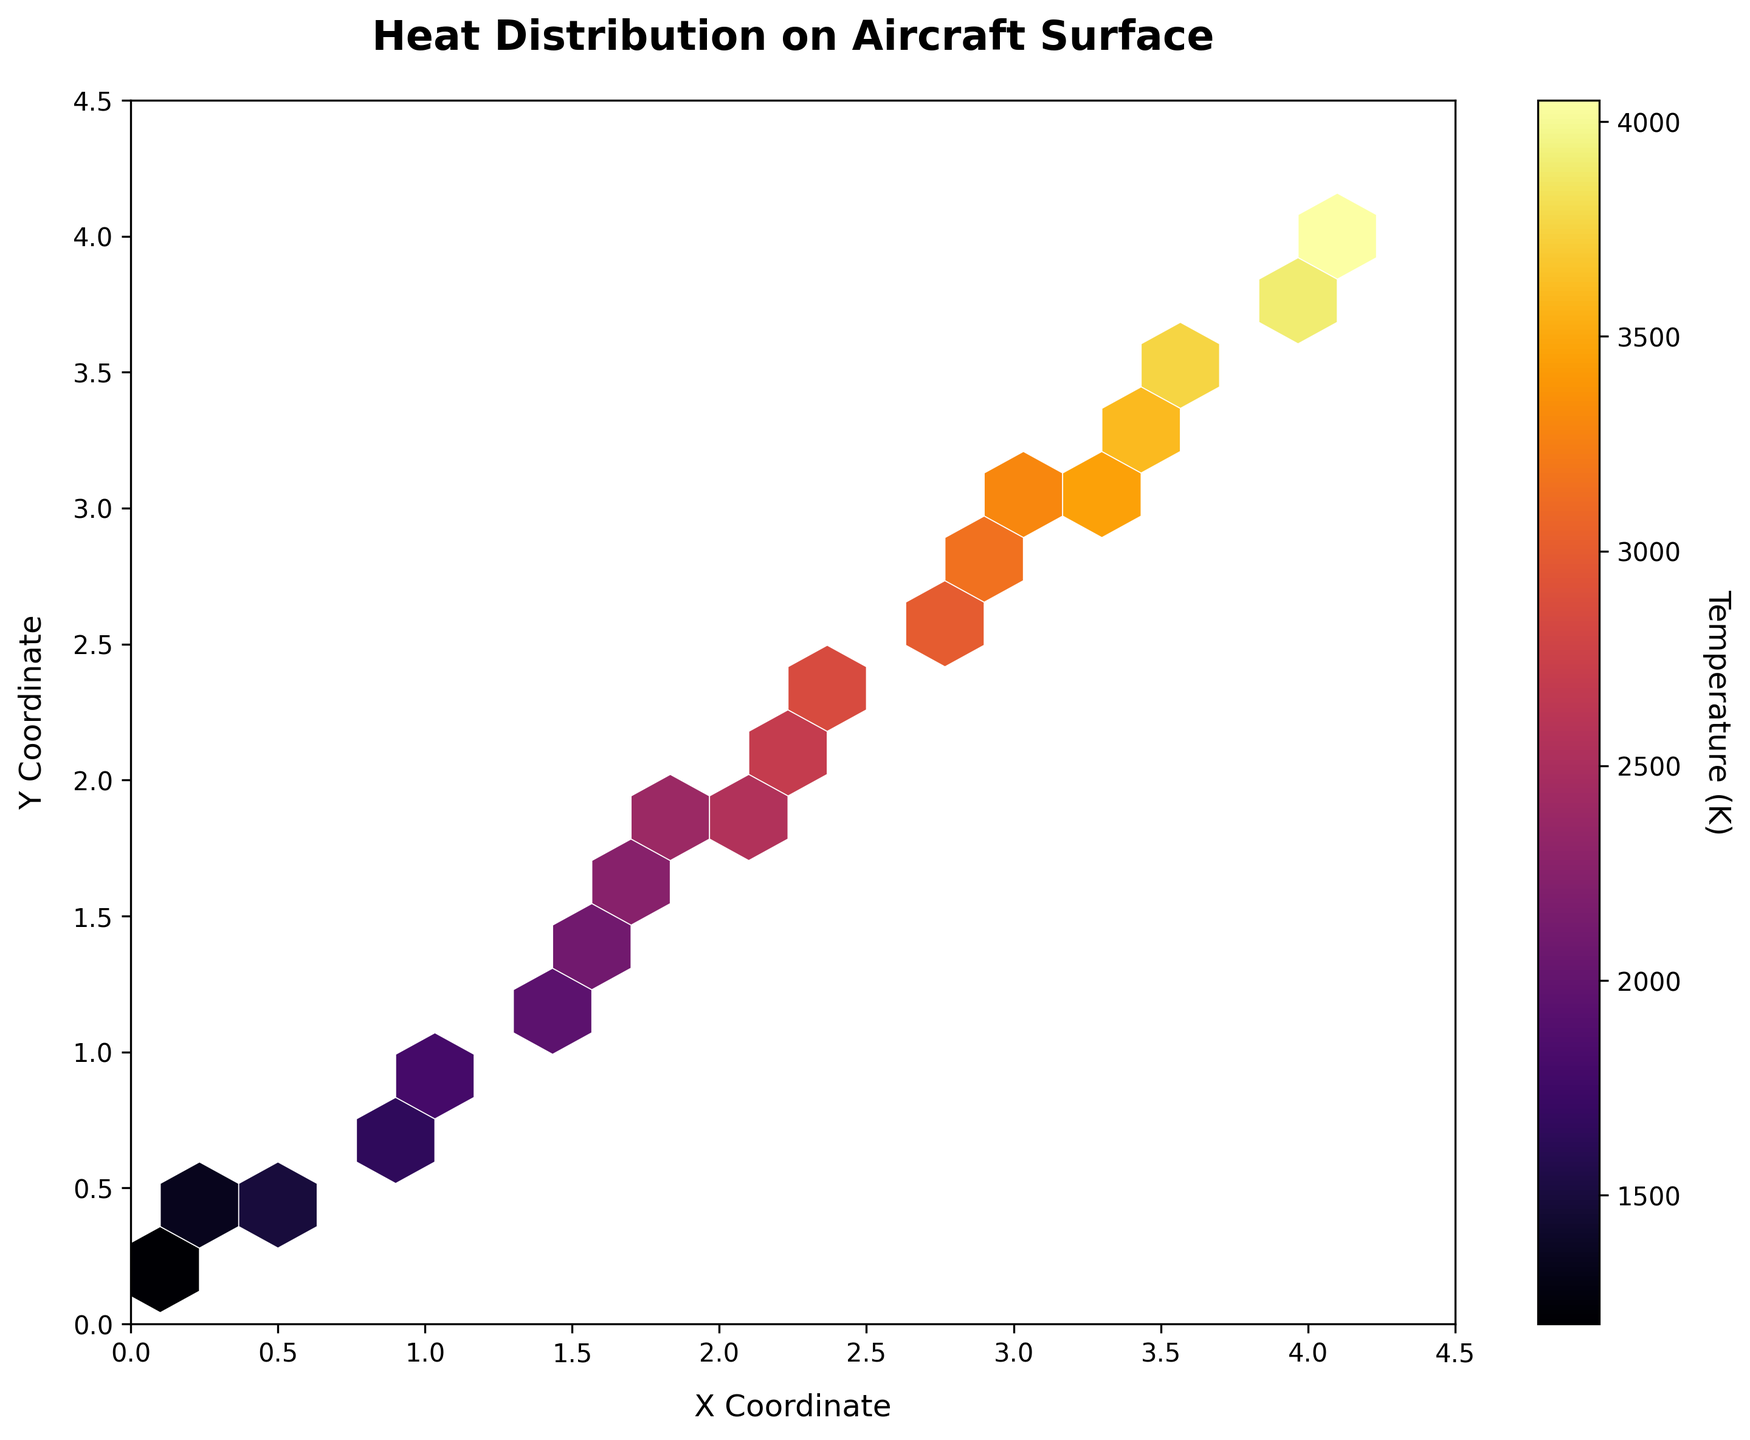What is the title of the figure? The title is often found at the top center of the figure. In this case, it explicitly describes what the plot represents.
Answer: Heat Distribution on Aircraft Surface What is the highest temperature registered in the plot? The color bar on the right of the plot indicates the temperature in Kelvin. The maximum color intensity corresponds to the maximum temperature value in the color bar.
Answer: 4050 K What is the color map used in the figure? Observing the shades used in the hexagonal bins and the color gradient in the color bar, we see it follows the 'inferno' color map, which progresses from dark purples to bright yellows and whites.
Answer: Inferno Which coordinate range does the X-axis cover? The x-axis label and tick marks indicate the span of the plotted area. The axis extends from the origin to a defined end point.
Answer: 0 to 4.5 How do the temperature distributions vary across different X coordinates? By observing the hexbin plot, note the color intensity variation across the X-axis. X-axis variations correspond to regions of different temperature densities.
Answer: Temperature increases Which area experiences the highest concentration of heat? The hexagonal bins with the brightest color indicate the highest heat concentration. Locate the brightest bins on the plot to determine the region.
Answer: Around (4, 4) How is the color bar labeled and oriented? The orientation and labeling of the color bar can be seen on the right-hand side of the plot. Observe the text and position to determine the details.
Answer: Vertically, labeled as Temperature (K) What is the grid size of the hexagonal bins? The hexagonal pattern's density gives an indication of the grid size used. If it's closely packed, the grid size is likely small and vice-versa.
Answer: 15 From the plot, how does the temperature change from (0, 0) to (4, 4)? By observing the gradient change in colors from the bottom-left to top-right, one can infer the temperature change. As colors shift from darker shades to brighter ones, the temperature increases.
Answer: Increases Which axis, X or Y, influences the temperature distributions more significantly? Observing the variation in color intensity along both axes, identify which axis shows a more pronounced gradient shift in temperatures.
Answer: X-axis 